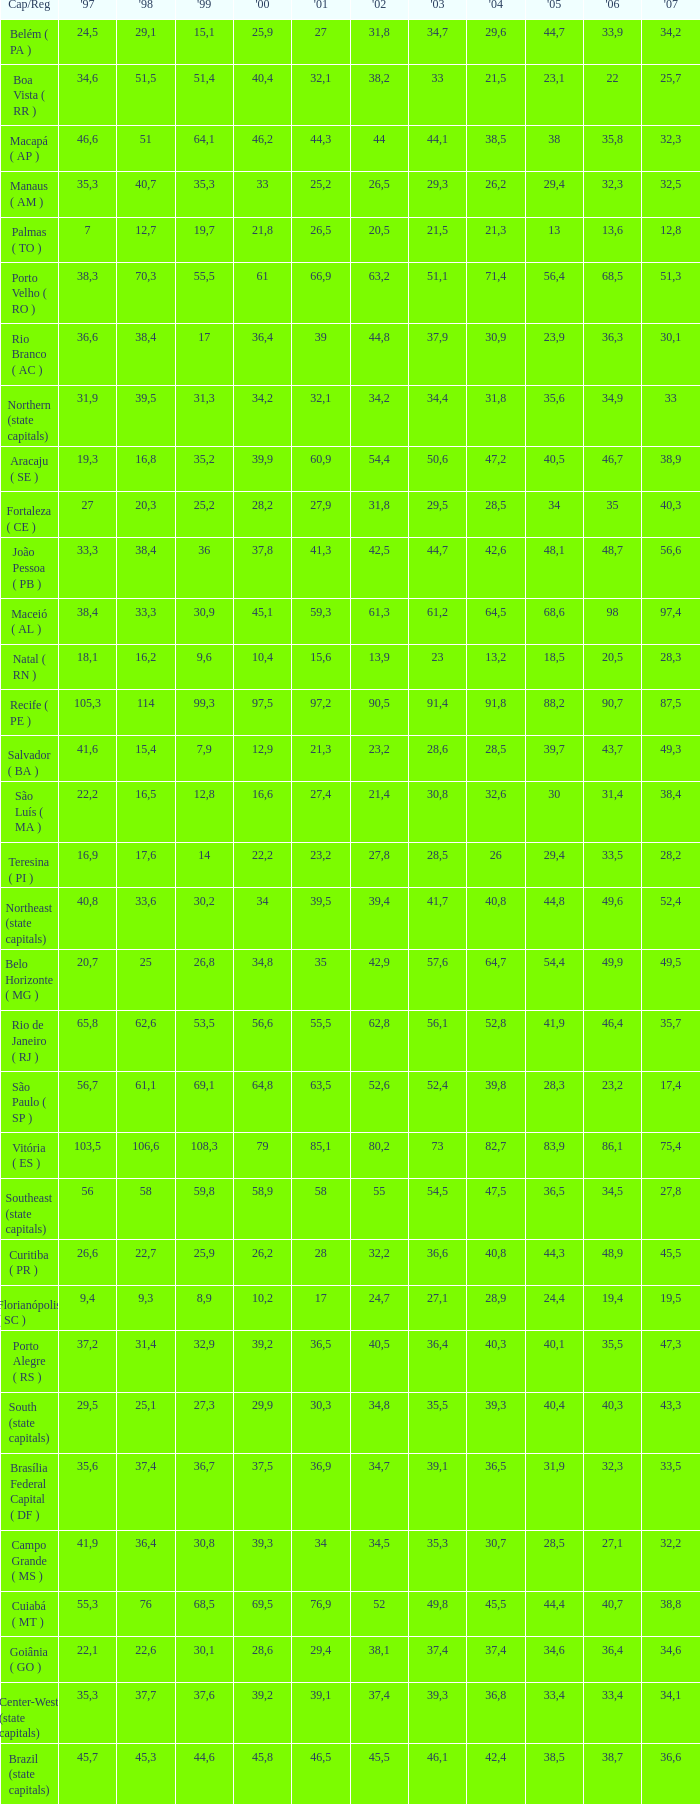How many 2007's have a 2000 greater than 56,6, 23,2 as 2006, and a 1998 greater than 61,1? None. 